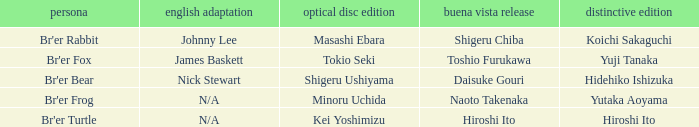What is the special edition where the english version is nick stewart? Hidehiko Ishizuka. Help me parse the entirety of this table. {'header': ['persona', 'english adaptation', 'optical disc edition', 'buena vista release', 'distinctive edition'], 'rows': [["Br'er Rabbit", 'Johnny Lee', 'Masashi Ebara', 'Shigeru Chiba', 'Koichi Sakaguchi'], ["Br'er Fox", 'James Baskett', 'Tokio Seki', 'Toshio Furukawa', 'Yuji Tanaka'], ["Br'er Bear", 'Nick Stewart', 'Shigeru Ushiyama', 'Daisuke Gouri', 'Hidehiko Ishizuka'], ["Br'er Frog", 'N/A', 'Minoru Uchida', 'Naoto Takenaka', 'Yutaka Aoyama'], ["Br'er Turtle", 'N/A', 'Kei Yoshimizu', 'Hiroshi Ito', 'Hiroshi Ito']]} 